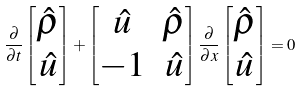<formula> <loc_0><loc_0><loc_500><loc_500>\frac { \partial } { \partial t } \begin{bmatrix} \hat { \rho } \\ \hat { u } \end{bmatrix} + \begin{bmatrix} \hat { u } & \hat { \rho } \\ - 1 & \hat { u } \end{bmatrix} \frac { \partial } { \partial x } \begin{bmatrix} \hat { \rho } \\ \hat { u } \end{bmatrix} = 0</formula> 